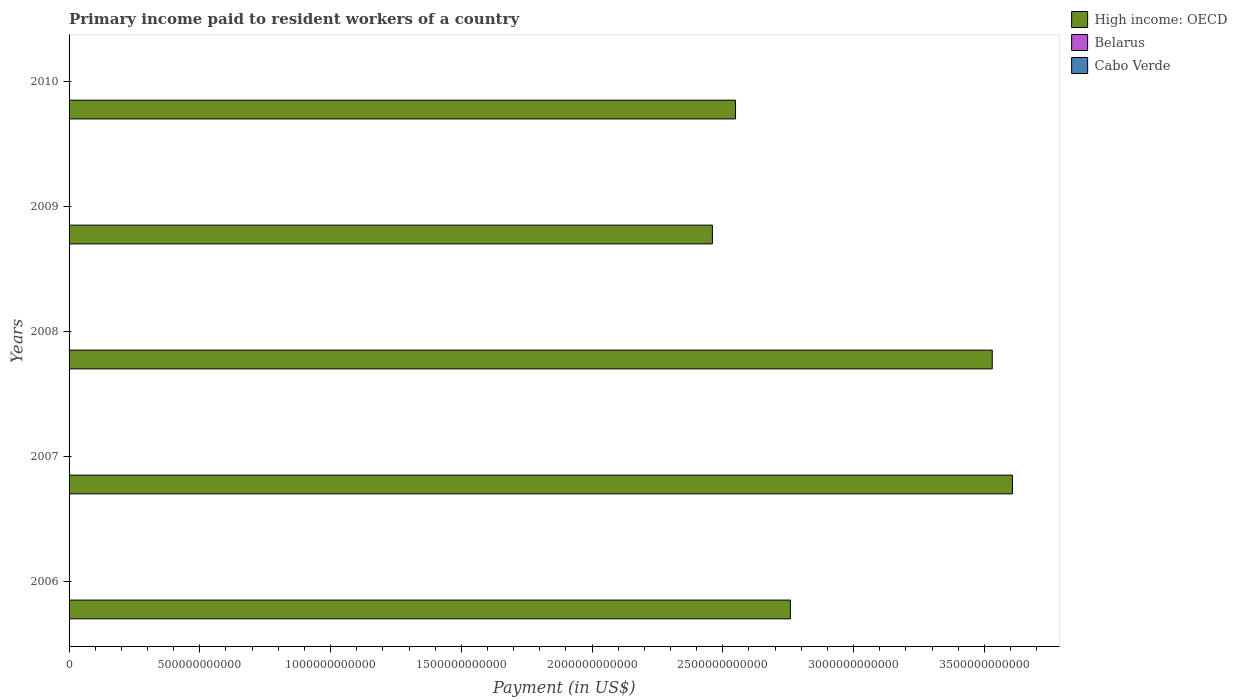How many different coloured bars are there?
Offer a very short reply. 3. How many bars are there on the 4th tick from the top?
Make the answer very short. 3. How many bars are there on the 1st tick from the bottom?
Provide a short and direct response. 3. What is the label of the 3rd group of bars from the top?
Your answer should be very brief. 2008. In how many cases, is the number of bars for a given year not equal to the number of legend labels?
Offer a terse response. 0. What is the amount paid to workers in Cabo Verde in 2006?
Your answer should be compact. 5.94e+07. Across all years, what is the maximum amount paid to workers in Belarus?
Your answer should be very brief. 1.60e+09. Across all years, what is the minimum amount paid to workers in High income: OECD?
Your response must be concise. 2.46e+12. In which year was the amount paid to workers in Cabo Verde maximum?
Your response must be concise. 2010. In which year was the amount paid to workers in Cabo Verde minimum?
Your answer should be very brief. 2007. What is the total amount paid to workers in High income: OECD in the graph?
Give a very brief answer. 1.49e+13. What is the difference between the amount paid to workers in Cabo Verde in 2007 and that in 2009?
Your answer should be compact. -7.39e+06. What is the difference between the amount paid to workers in Belarus in 2010 and the amount paid to workers in Cabo Verde in 2008?
Offer a terse response. 1.52e+09. What is the average amount paid to workers in High income: OECD per year?
Your answer should be very brief. 2.98e+12. In the year 2008, what is the difference between the amount paid to workers in Cabo Verde and amount paid to workers in High income: OECD?
Provide a succinct answer. -3.53e+12. What is the ratio of the amount paid to workers in Belarus in 2009 to that in 2010?
Offer a very short reply. 0.82. Is the amount paid to workers in High income: OECD in 2008 less than that in 2009?
Make the answer very short. No. Is the difference between the amount paid to workers in Cabo Verde in 2006 and 2009 greater than the difference between the amount paid to workers in High income: OECD in 2006 and 2009?
Give a very brief answer. No. What is the difference between the highest and the second highest amount paid to workers in Cabo Verde?
Your response must be concise. 1.73e+07. What is the difference between the highest and the lowest amount paid to workers in Cabo Verde?
Your answer should be very brief. 3.42e+07. Is the sum of the amount paid to workers in Cabo Verde in 2007 and 2008 greater than the maximum amount paid to workers in Belarus across all years?
Offer a terse response. No. What does the 2nd bar from the top in 2006 represents?
Your answer should be compact. Belarus. What does the 1st bar from the bottom in 2008 represents?
Give a very brief answer. High income: OECD. Is it the case that in every year, the sum of the amount paid to workers in High income: OECD and amount paid to workers in Belarus is greater than the amount paid to workers in Cabo Verde?
Keep it short and to the point. Yes. Are all the bars in the graph horizontal?
Provide a succinct answer. Yes. What is the difference between two consecutive major ticks on the X-axis?
Your response must be concise. 5.00e+11. Are the values on the major ticks of X-axis written in scientific E-notation?
Keep it short and to the point. No. Does the graph contain any zero values?
Give a very brief answer. No. Where does the legend appear in the graph?
Ensure brevity in your answer.  Top right. How many legend labels are there?
Give a very brief answer. 3. How are the legend labels stacked?
Offer a terse response. Vertical. What is the title of the graph?
Keep it short and to the point. Primary income paid to resident workers of a country. What is the label or title of the X-axis?
Your answer should be very brief. Payment (in US$). What is the label or title of the Y-axis?
Give a very brief answer. Years. What is the Payment (in US$) in High income: OECD in 2006?
Offer a terse response. 2.76e+12. What is the Payment (in US$) in Belarus in 2006?
Your response must be concise. 3.46e+08. What is the Payment (in US$) of Cabo Verde in 2006?
Your answer should be very brief. 5.94e+07. What is the Payment (in US$) in High income: OECD in 2007?
Your answer should be very brief. 3.61e+12. What is the Payment (in US$) in Belarus in 2007?
Provide a succinct answer. 6.62e+08. What is the Payment (in US$) of Cabo Verde in 2007?
Make the answer very short. 5.89e+07. What is the Payment (in US$) of High income: OECD in 2008?
Your answer should be compact. 3.53e+12. What is the Payment (in US$) of Belarus in 2008?
Your answer should be compact. 1.14e+09. What is the Payment (in US$) of Cabo Verde in 2008?
Your answer should be very brief. 7.57e+07. What is the Payment (in US$) of High income: OECD in 2009?
Give a very brief answer. 2.46e+12. What is the Payment (in US$) in Belarus in 2009?
Keep it short and to the point. 1.31e+09. What is the Payment (in US$) of Cabo Verde in 2009?
Your response must be concise. 6.63e+07. What is the Payment (in US$) of High income: OECD in 2010?
Offer a terse response. 2.55e+12. What is the Payment (in US$) of Belarus in 2010?
Ensure brevity in your answer.  1.60e+09. What is the Payment (in US$) in Cabo Verde in 2010?
Provide a succinct answer. 9.31e+07. Across all years, what is the maximum Payment (in US$) of High income: OECD?
Give a very brief answer. 3.61e+12. Across all years, what is the maximum Payment (in US$) of Belarus?
Your answer should be very brief. 1.60e+09. Across all years, what is the maximum Payment (in US$) in Cabo Verde?
Offer a very short reply. 9.31e+07. Across all years, what is the minimum Payment (in US$) in High income: OECD?
Make the answer very short. 2.46e+12. Across all years, what is the minimum Payment (in US$) in Belarus?
Give a very brief answer. 3.46e+08. Across all years, what is the minimum Payment (in US$) of Cabo Verde?
Provide a short and direct response. 5.89e+07. What is the total Payment (in US$) in High income: OECD in the graph?
Make the answer very short. 1.49e+13. What is the total Payment (in US$) of Belarus in the graph?
Offer a terse response. 5.05e+09. What is the total Payment (in US$) of Cabo Verde in the graph?
Make the answer very short. 3.53e+08. What is the difference between the Payment (in US$) in High income: OECD in 2006 and that in 2007?
Provide a short and direct response. -8.49e+11. What is the difference between the Payment (in US$) in Belarus in 2006 and that in 2007?
Give a very brief answer. -3.16e+08. What is the difference between the Payment (in US$) in Cabo Verde in 2006 and that in 2007?
Keep it short and to the point. 4.88e+05. What is the difference between the Payment (in US$) of High income: OECD in 2006 and that in 2008?
Ensure brevity in your answer.  -7.72e+11. What is the difference between the Payment (in US$) of Belarus in 2006 and that in 2008?
Your response must be concise. -7.91e+08. What is the difference between the Payment (in US$) of Cabo Verde in 2006 and that in 2008?
Offer a terse response. -1.63e+07. What is the difference between the Payment (in US$) of High income: OECD in 2006 and that in 2009?
Your response must be concise. 2.98e+11. What is the difference between the Payment (in US$) of Belarus in 2006 and that in 2009?
Keep it short and to the point. -9.60e+08. What is the difference between the Payment (in US$) in Cabo Verde in 2006 and that in 2009?
Offer a very short reply. -6.90e+06. What is the difference between the Payment (in US$) of High income: OECD in 2006 and that in 2010?
Offer a terse response. 2.10e+11. What is the difference between the Payment (in US$) of Belarus in 2006 and that in 2010?
Your response must be concise. -1.25e+09. What is the difference between the Payment (in US$) in Cabo Verde in 2006 and that in 2010?
Your answer should be very brief. -3.37e+07. What is the difference between the Payment (in US$) in High income: OECD in 2007 and that in 2008?
Provide a short and direct response. 7.73e+1. What is the difference between the Payment (in US$) of Belarus in 2007 and that in 2008?
Your answer should be very brief. -4.75e+08. What is the difference between the Payment (in US$) in Cabo Verde in 2007 and that in 2008?
Your answer should be very brief. -1.68e+07. What is the difference between the Payment (in US$) of High income: OECD in 2007 and that in 2009?
Ensure brevity in your answer.  1.15e+12. What is the difference between the Payment (in US$) in Belarus in 2007 and that in 2009?
Your answer should be compact. -6.44e+08. What is the difference between the Payment (in US$) of Cabo Verde in 2007 and that in 2009?
Keep it short and to the point. -7.39e+06. What is the difference between the Payment (in US$) in High income: OECD in 2007 and that in 2010?
Keep it short and to the point. 1.06e+12. What is the difference between the Payment (in US$) in Belarus in 2007 and that in 2010?
Give a very brief answer. -9.38e+08. What is the difference between the Payment (in US$) of Cabo Verde in 2007 and that in 2010?
Keep it short and to the point. -3.42e+07. What is the difference between the Payment (in US$) of High income: OECD in 2008 and that in 2009?
Offer a very short reply. 1.07e+12. What is the difference between the Payment (in US$) of Belarus in 2008 and that in 2009?
Make the answer very short. -1.69e+08. What is the difference between the Payment (in US$) of Cabo Verde in 2008 and that in 2009?
Your response must be concise. 9.44e+06. What is the difference between the Payment (in US$) in High income: OECD in 2008 and that in 2010?
Your answer should be compact. 9.82e+11. What is the difference between the Payment (in US$) of Belarus in 2008 and that in 2010?
Ensure brevity in your answer.  -4.62e+08. What is the difference between the Payment (in US$) in Cabo Verde in 2008 and that in 2010?
Offer a terse response. -1.73e+07. What is the difference between the Payment (in US$) of High income: OECD in 2009 and that in 2010?
Keep it short and to the point. -8.86e+1. What is the difference between the Payment (in US$) in Belarus in 2009 and that in 2010?
Make the answer very short. -2.94e+08. What is the difference between the Payment (in US$) of Cabo Verde in 2009 and that in 2010?
Give a very brief answer. -2.68e+07. What is the difference between the Payment (in US$) of High income: OECD in 2006 and the Payment (in US$) of Belarus in 2007?
Give a very brief answer. 2.76e+12. What is the difference between the Payment (in US$) in High income: OECD in 2006 and the Payment (in US$) in Cabo Verde in 2007?
Provide a succinct answer. 2.76e+12. What is the difference between the Payment (in US$) of Belarus in 2006 and the Payment (in US$) of Cabo Verde in 2007?
Make the answer very short. 2.87e+08. What is the difference between the Payment (in US$) in High income: OECD in 2006 and the Payment (in US$) in Belarus in 2008?
Provide a succinct answer. 2.76e+12. What is the difference between the Payment (in US$) of High income: OECD in 2006 and the Payment (in US$) of Cabo Verde in 2008?
Provide a short and direct response. 2.76e+12. What is the difference between the Payment (in US$) in Belarus in 2006 and the Payment (in US$) in Cabo Verde in 2008?
Ensure brevity in your answer.  2.71e+08. What is the difference between the Payment (in US$) in High income: OECD in 2006 and the Payment (in US$) in Belarus in 2009?
Provide a short and direct response. 2.76e+12. What is the difference between the Payment (in US$) of High income: OECD in 2006 and the Payment (in US$) of Cabo Verde in 2009?
Keep it short and to the point. 2.76e+12. What is the difference between the Payment (in US$) in Belarus in 2006 and the Payment (in US$) in Cabo Verde in 2009?
Give a very brief answer. 2.80e+08. What is the difference between the Payment (in US$) of High income: OECD in 2006 and the Payment (in US$) of Belarus in 2010?
Give a very brief answer. 2.76e+12. What is the difference between the Payment (in US$) of High income: OECD in 2006 and the Payment (in US$) of Cabo Verde in 2010?
Your response must be concise. 2.76e+12. What is the difference between the Payment (in US$) of Belarus in 2006 and the Payment (in US$) of Cabo Verde in 2010?
Give a very brief answer. 2.53e+08. What is the difference between the Payment (in US$) in High income: OECD in 2007 and the Payment (in US$) in Belarus in 2008?
Provide a short and direct response. 3.61e+12. What is the difference between the Payment (in US$) in High income: OECD in 2007 and the Payment (in US$) in Cabo Verde in 2008?
Provide a succinct answer. 3.61e+12. What is the difference between the Payment (in US$) of Belarus in 2007 and the Payment (in US$) of Cabo Verde in 2008?
Offer a terse response. 5.86e+08. What is the difference between the Payment (in US$) in High income: OECD in 2007 and the Payment (in US$) in Belarus in 2009?
Make the answer very short. 3.61e+12. What is the difference between the Payment (in US$) of High income: OECD in 2007 and the Payment (in US$) of Cabo Verde in 2009?
Your answer should be very brief. 3.61e+12. What is the difference between the Payment (in US$) in Belarus in 2007 and the Payment (in US$) in Cabo Verde in 2009?
Give a very brief answer. 5.96e+08. What is the difference between the Payment (in US$) in High income: OECD in 2007 and the Payment (in US$) in Belarus in 2010?
Keep it short and to the point. 3.61e+12. What is the difference between the Payment (in US$) of High income: OECD in 2007 and the Payment (in US$) of Cabo Verde in 2010?
Give a very brief answer. 3.61e+12. What is the difference between the Payment (in US$) in Belarus in 2007 and the Payment (in US$) in Cabo Verde in 2010?
Your answer should be compact. 5.69e+08. What is the difference between the Payment (in US$) of High income: OECD in 2008 and the Payment (in US$) of Belarus in 2009?
Your answer should be compact. 3.53e+12. What is the difference between the Payment (in US$) in High income: OECD in 2008 and the Payment (in US$) in Cabo Verde in 2009?
Make the answer very short. 3.53e+12. What is the difference between the Payment (in US$) in Belarus in 2008 and the Payment (in US$) in Cabo Verde in 2009?
Your response must be concise. 1.07e+09. What is the difference between the Payment (in US$) in High income: OECD in 2008 and the Payment (in US$) in Belarus in 2010?
Offer a very short reply. 3.53e+12. What is the difference between the Payment (in US$) in High income: OECD in 2008 and the Payment (in US$) in Cabo Verde in 2010?
Keep it short and to the point. 3.53e+12. What is the difference between the Payment (in US$) of Belarus in 2008 and the Payment (in US$) of Cabo Verde in 2010?
Make the answer very short. 1.04e+09. What is the difference between the Payment (in US$) in High income: OECD in 2009 and the Payment (in US$) in Belarus in 2010?
Your response must be concise. 2.46e+12. What is the difference between the Payment (in US$) of High income: OECD in 2009 and the Payment (in US$) of Cabo Verde in 2010?
Your answer should be compact. 2.46e+12. What is the difference between the Payment (in US$) of Belarus in 2009 and the Payment (in US$) of Cabo Verde in 2010?
Provide a succinct answer. 1.21e+09. What is the average Payment (in US$) in High income: OECD per year?
Provide a short and direct response. 2.98e+12. What is the average Payment (in US$) of Belarus per year?
Give a very brief answer. 1.01e+09. What is the average Payment (in US$) of Cabo Verde per year?
Offer a terse response. 7.07e+07. In the year 2006, what is the difference between the Payment (in US$) in High income: OECD and Payment (in US$) in Belarus?
Your answer should be very brief. 2.76e+12. In the year 2006, what is the difference between the Payment (in US$) of High income: OECD and Payment (in US$) of Cabo Verde?
Offer a terse response. 2.76e+12. In the year 2006, what is the difference between the Payment (in US$) in Belarus and Payment (in US$) in Cabo Verde?
Keep it short and to the point. 2.87e+08. In the year 2007, what is the difference between the Payment (in US$) in High income: OECD and Payment (in US$) in Belarus?
Make the answer very short. 3.61e+12. In the year 2007, what is the difference between the Payment (in US$) in High income: OECD and Payment (in US$) in Cabo Verde?
Provide a short and direct response. 3.61e+12. In the year 2007, what is the difference between the Payment (in US$) in Belarus and Payment (in US$) in Cabo Verde?
Keep it short and to the point. 6.03e+08. In the year 2008, what is the difference between the Payment (in US$) of High income: OECD and Payment (in US$) of Belarus?
Offer a terse response. 3.53e+12. In the year 2008, what is the difference between the Payment (in US$) in High income: OECD and Payment (in US$) in Cabo Verde?
Keep it short and to the point. 3.53e+12. In the year 2008, what is the difference between the Payment (in US$) of Belarus and Payment (in US$) of Cabo Verde?
Your answer should be very brief. 1.06e+09. In the year 2009, what is the difference between the Payment (in US$) of High income: OECD and Payment (in US$) of Belarus?
Provide a succinct answer. 2.46e+12. In the year 2009, what is the difference between the Payment (in US$) of High income: OECD and Payment (in US$) of Cabo Verde?
Offer a terse response. 2.46e+12. In the year 2009, what is the difference between the Payment (in US$) in Belarus and Payment (in US$) in Cabo Verde?
Your response must be concise. 1.24e+09. In the year 2010, what is the difference between the Payment (in US$) in High income: OECD and Payment (in US$) in Belarus?
Keep it short and to the point. 2.55e+12. In the year 2010, what is the difference between the Payment (in US$) in High income: OECD and Payment (in US$) in Cabo Verde?
Ensure brevity in your answer.  2.55e+12. In the year 2010, what is the difference between the Payment (in US$) of Belarus and Payment (in US$) of Cabo Verde?
Your answer should be very brief. 1.51e+09. What is the ratio of the Payment (in US$) in High income: OECD in 2006 to that in 2007?
Give a very brief answer. 0.76. What is the ratio of the Payment (in US$) of Belarus in 2006 to that in 2007?
Make the answer very short. 0.52. What is the ratio of the Payment (in US$) of Cabo Verde in 2006 to that in 2007?
Your answer should be compact. 1.01. What is the ratio of the Payment (in US$) in High income: OECD in 2006 to that in 2008?
Your answer should be very brief. 0.78. What is the ratio of the Payment (in US$) in Belarus in 2006 to that in 2008?
Make the answer very short. 0.3. What is the ratio of the Payment (in US$) in Cabo Verde in 2006 to that in 2008?
Provide a succinct answer. 0.78. What is the ratio of the Payment (in US$) of High income: OECD in 2006 to that in 2009?
Offer a very short reply. 1.12. What is the ratio of the Payment (in US$) of Belarus in 2006 to that in 2009?
Offer a terse response. 0.27. What is the ratio of the Payment (in US$) of Cabo Verde in 2006 to that in 2009?
Offer a very short reply. 0.9. What is the ratio of the Payment (in US$) in High income: OECD in 2006 to that in 2010?
Ensure brevity in your answer.  1.08. What is the ratio of the Payment (in US$) of Belarus in 2006 to that in 2010?
Your answer should be very brief. 0.22. What is the ratio of the Payment (in US$) of Cabo Verde in 2006 to that in 2010?
Your answer should be compact. 0.64. What is the ratio of the Payment (in US$) in High income: OECD in 2007 to that in 2008?
Provide a succinct answer. 1.02. What is the ratio of the Payment (in US$) in Belarus in 2007 to that in 2008?
Give a very brief answer. 0.58. What is the ratio of the Payment (in US$) in Cabo Verde in 2007 to that in 2008?
Ensure brevity in your answer.  0.78. What is the ratio of the Payment (in US$) of High income: OECD in 2007 to that in 2009?
Ensure brevity in your answer.  1.47. What is the ratio of the Payment (in US$) in Belarus in 2007 to that in 2009?
Your response must be concise. 0.51. What is the ratio of the Payment (in US$) of Cabo Verde in 2007 to that in 2009?
Give a very brief answer. 0.89. What is the ratio of the Payment (in US$) of High income: OECD in 2007 to that in 2010?
Your answer should be very brief. 1.42. What is the ratio of the Payment (in US$) of Belarus in 2007 to that in 2010?
Offer a very short reply. 0.41. What is the ratio of the Payment (in US$) of Cabo Verde in 2007 to that in 2010?
Keep it short and to the point. 0.63. What is the ratio of the Payment (in US$) in High income: OECD in 2008 to that in 2009?
Ensure brevity in your answer.  1.44. What is the ratio of the Payment (in US$) in Belarus in 2008 to that in 2009?
Offer a terse response. 0.87. What is the ratio of the Payment (in US$) in Cabo Verde in 2008 to that in 2009?
Your answer should be compact. 1.14. What is the ratio of the Payment (in US$) of High income: OECD in 2008 to that in 2010?
Provide a short and direct response. 1.39. What is the ratio of the Payment (in US$) in Belarus in 2008 to that in 2010?
Provide a short and direct response. 0.71. What is the ratio of the Payment (in US$) of Cabo Verde in 2008 to that in 2010?
Keep it short and to the point. 0.81. What is the ratio of the Payment (in US$) of High income: OECD in 2009 to that in 2010?
Make the answer very short. 0.97. What is the ratio of the Payment (in US$) in Belarus in 2009 to that in 2010?
Offer a terse response. 0.82. What is the ratio of the Payment (in US$) in Cabo Verde in 2009 to that in 2010?
Offer a very short reply. 0.71. What is the difference between the highest and the second highest Payment (in US$) in High income: OECD?
Offer a very short reply. 7.73e+1. What is the difference between the highest and the second highest Payment (in US$) of Belarus?
Keep it short and to the point. 2.94e+08. What is the difference between the highest and the second highest Payment (in US$) of Cabo Verde?
Make the answer very short. 1.73e+07. What is the difference between the highest and the lowest Payment (in US$) in High income: OECD?
Your answer should be very brief. 1.15e+12. What is the difference between the highest and the lowest Payment (in US$) in Belarus?
Make the answer very short. 1.25e+09. What is the difference between the highest and the lowest Payment (in US$) in Cabo Verde?
Give a very brief answer. 3.42e+07. 